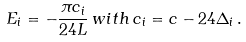<formula> <loc_0><loc_0><loc_500><loc_500>E _ { i } = - \frac { \pi c _ { i } } { 2 4 L } \, w i t h \, c _ { i } = c - 2 4 \Delta _ { i } \, .</formula> 